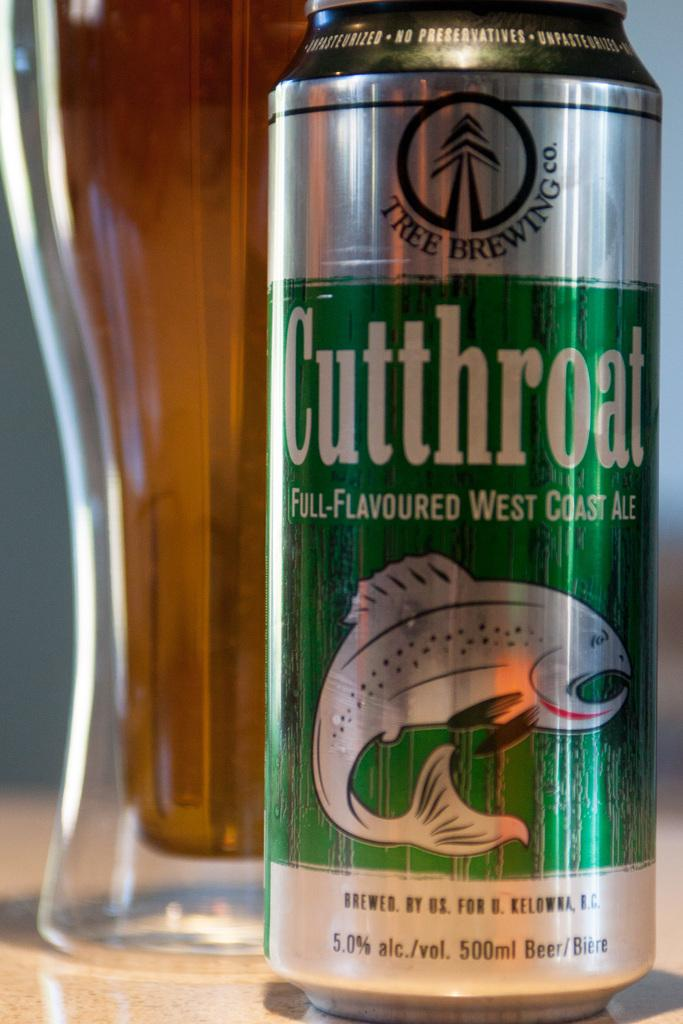<image>
Give a short and clear explanation of the subsequent image. A can of Cutthroat ale features a fish on the label. 